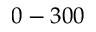<formula> <loc_0><loc_0><loc_500><loc_500>0 - 3 0 0</formula> 